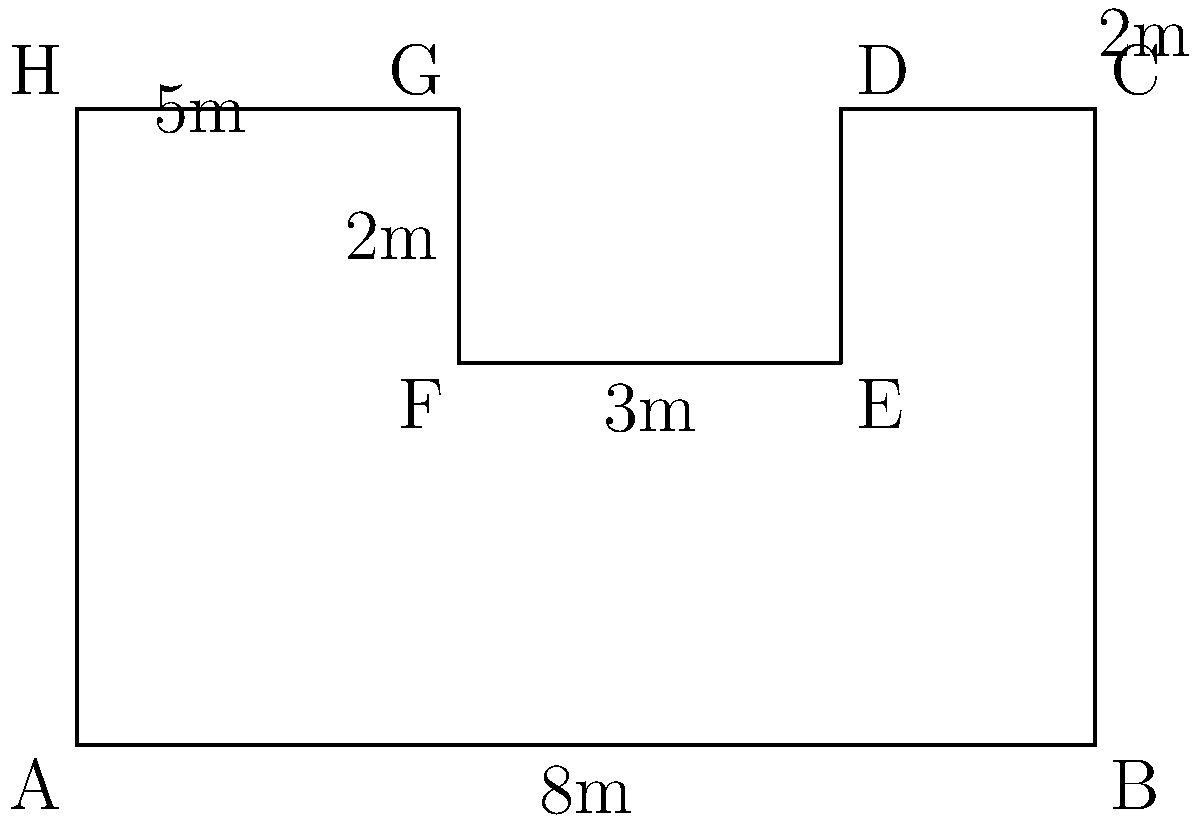As a construction worker, you're tasked with fencing an irregularly shaped construction site. The site's layout is shown in the diagram above, with measurements in meters. What is the total perimeter of the construction site that needs to be fenced? To calculate the perimeter, we need to add up the lengths of all sides of the irregular shape:

1. Side AB: $8$ m (given)
2. Side BC: $5$ m (given)
3. Side CD: $2$ m (C to D)
4. Side DE: $2$ m (from 5m - 3m)
5. Side EF: $3$ m (given)
6. Side FG: $2$ m (given)
7. Side GH: $3$ m (from 8m - 5m)
8. Side HA: $5$ m (given)

Now, let's add all these lengths:

$$ \text{Perimeter} = 8 + 5 + 2 + 2 + 3 + 2 + 3 + 5 = 30 \text{ m} $$

Therefore, the total perimeter of the construction site that needs to be fenced is 30 meters.
Answer: $30 \text{ m}$ 